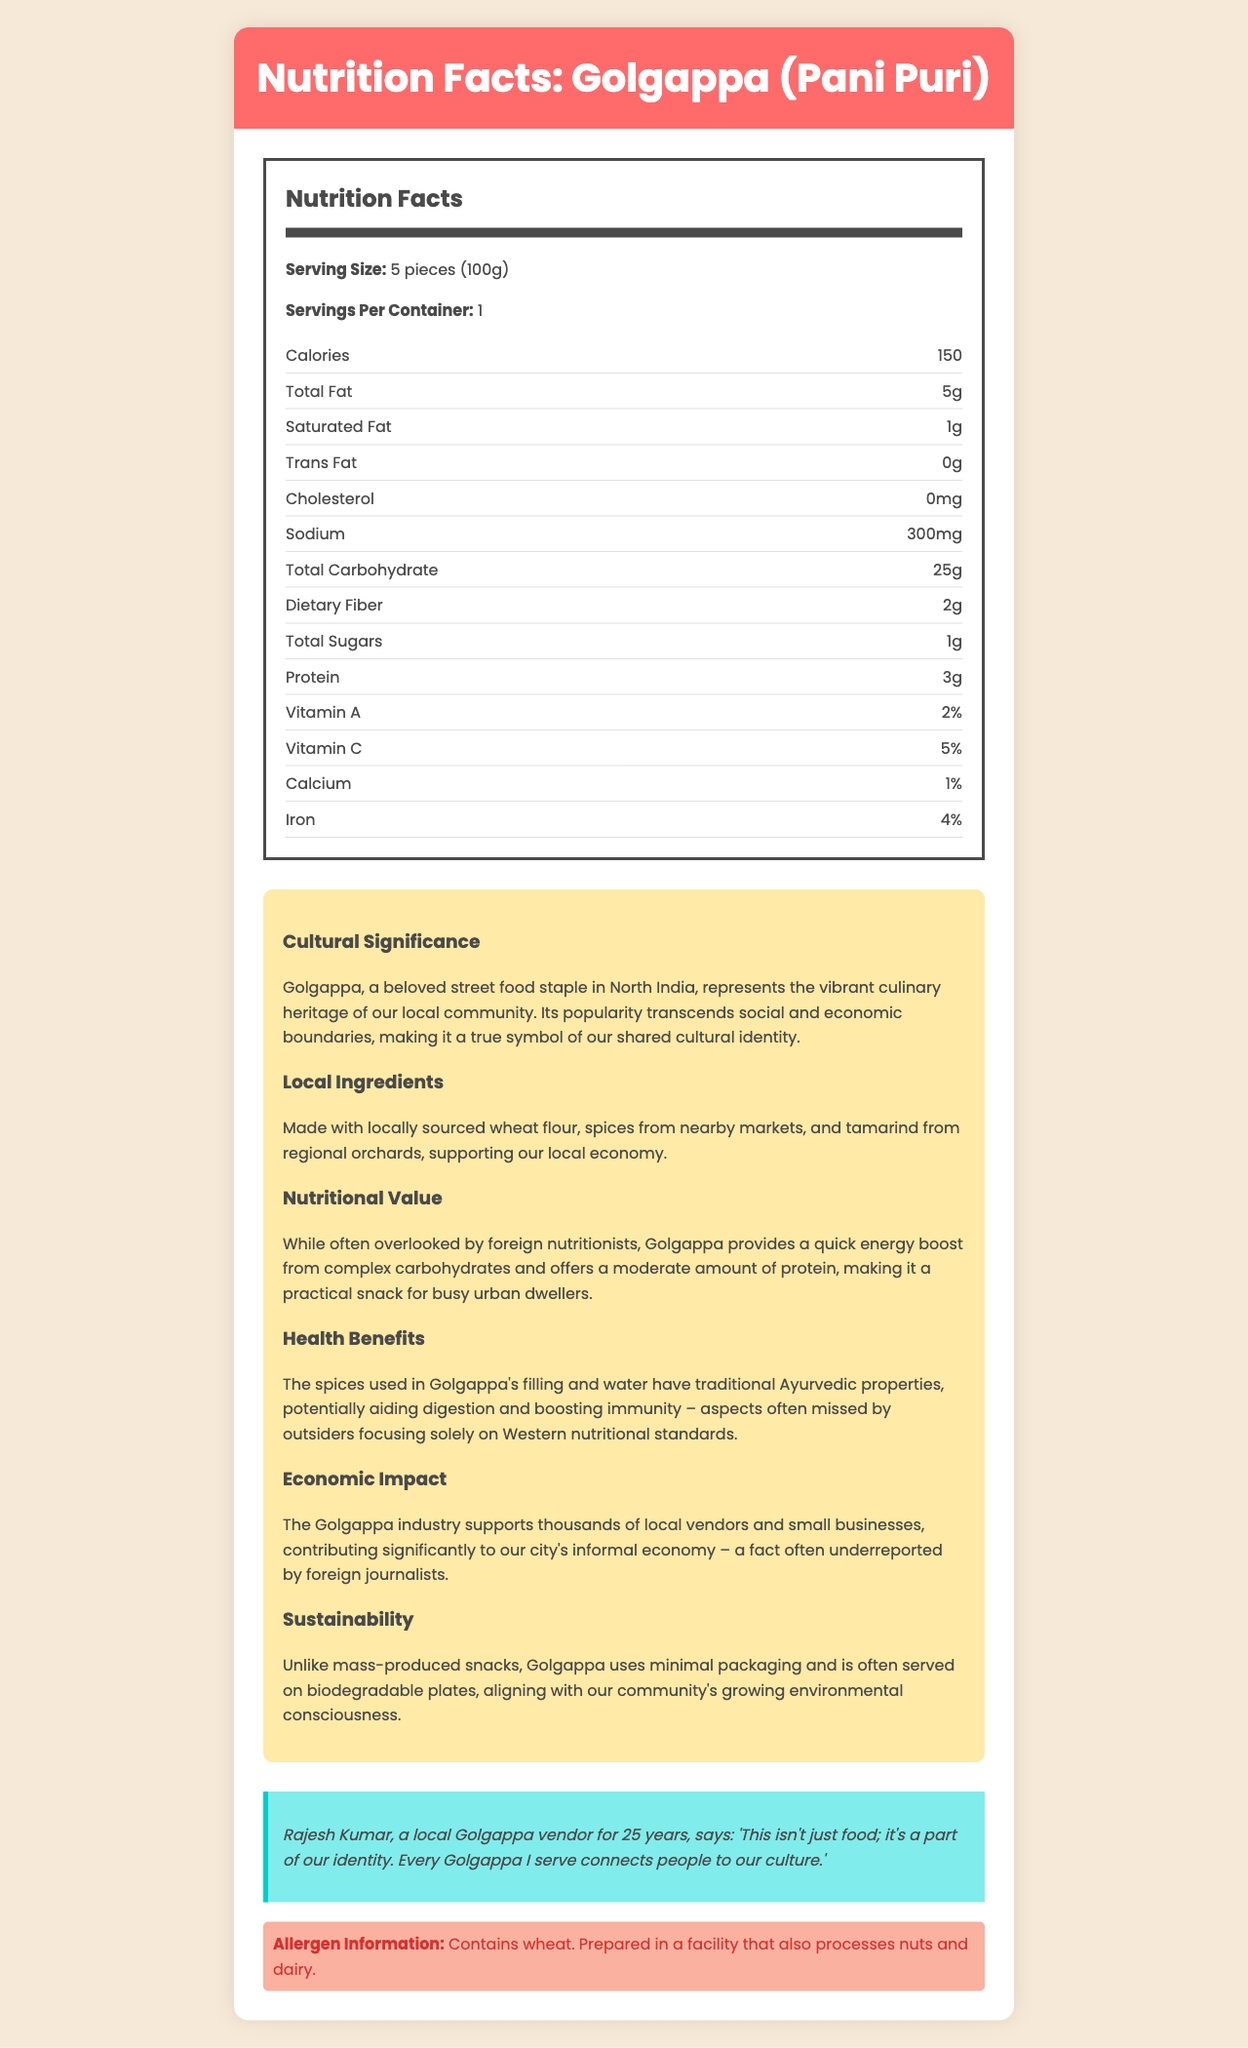what is the serving size for Golgappa (Pani Puri)? The serving size is mentioned at the beginning of the Nutrition Facts section under "Serving Size".
Answer: 5 pieces (100g) how many calories are in one serving of Golgappa? The number of calories per serving is clearly noted in the Nutrition Facts section.
Answer: 150 what are the traditional health benefits of the spices used in Golgappa? The cultural information mentions that the spices have Ayurvedic properties that can aid digestion and boost immunity.
Answer: Aiding digestion and boosting immunity how much sodium does one serving contain? The amount of sodium per serving is detailed in the Nutrition Facts section.
Answer: 300 mg how much protein is in a serving of Golgappa? The protein content is listed in the Nutrition Facts section.
Answer: 3 grams what percentage of daily Vitamin C is provided by one serving? The Vitamin C content is listed with a daily percentage value in the Nutrition Facts section.
Answer: 5% which local sectors benefit economically from the Golgappa industry? A. Healthcare B. Small businesses and local vendors C. Large corporations D. Tourism The document mentions that the Golgappa industry supports thousands of local vendors and small businesses.
Answer: B what type of packaging is used for serving Golgappa? A. Plastic containers B. Biodegradable plates C. Metal trays D. Paper bags The sustainability section mentions that Golgappa is often served on biodegradable plates.
Answer: B is Golgappa gluten-free? The allergen information specifies that Golgappa contains wheat.
Answer: No the nutritional value of Golgappa is mainly derived from which macronutrient? The nutritional value section highlights that Golgappa provides a quick energy boost from complex carbohydrates.
Answer: Complex carbohydrates summarize the main cultural and economic significance of Golgappa as presented in the document. The document discusses the cultural significance, nutritional value, health benefits, and economic impact of Golgappa, highlighting its importance in local heritage and economy.
Answer: Golgappa, a popular street food in North India, symbolizes the vibrant culinary heritage and shared cultural identity of the local community. It supports the local economy by utilizing locally sourced ingredients and providing income for numerous vendors and small businesses, contributing significantly to the informal economy. It also aligns with environmental consciousness through minimal packaging. how long has Rajesh Kumar been a Golgappa vendor according to the document? The vendor quote in the document mentions that Rajesh Kumar has been a vendor for 25 years.
Answer: 25 years what is the total carbohydrate content in one serving? The Nutrition Facts section lists the total carbohydrate content per serving.
Answer: 25 grams who is Rajesh Kumar and what does he say about Golgappa? The vendor quote section gives information about Rajesh Kumar and his view on Golgappa.
Answer: A local vendor; he says it's a part of cultural identity and connects people to culture. can you determine the exact percentage of dietary fiber provided by one serving? The document lists the dietary fiber content as 2 grams but does not provide the daily percentage value.
Answer: Cannot be determined 